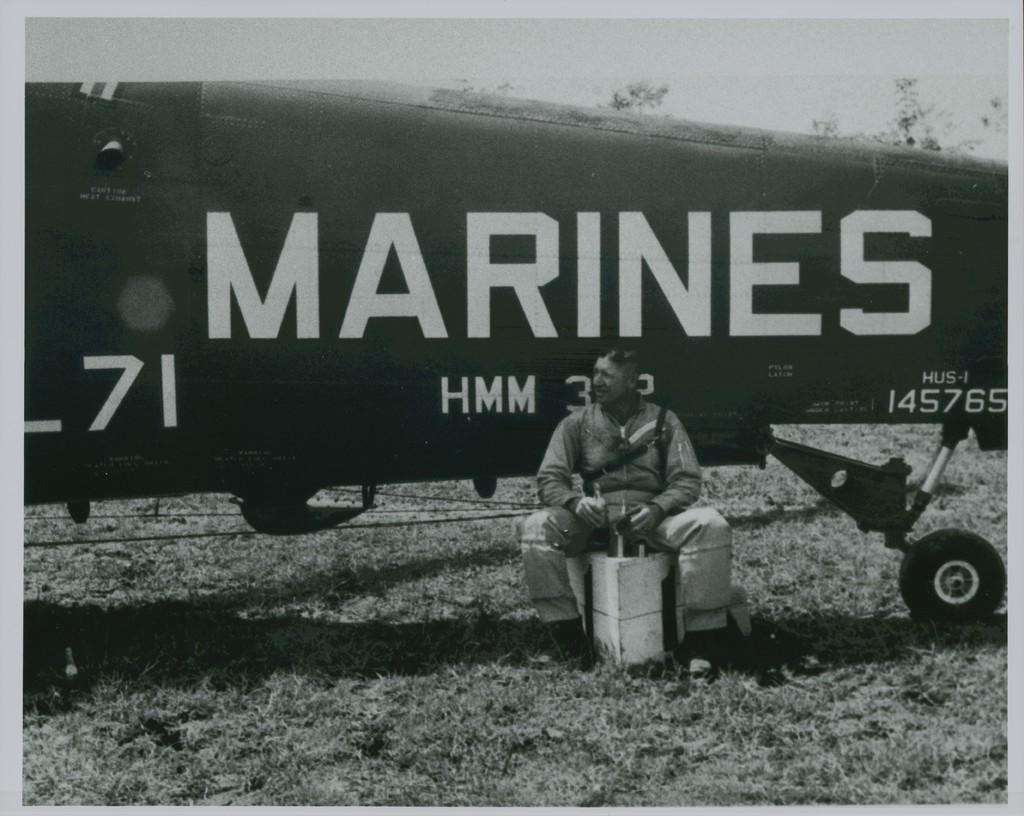<image>
Present a compact description of the photo's key features. Airplane with Marines and HMM wrote on the left side. 